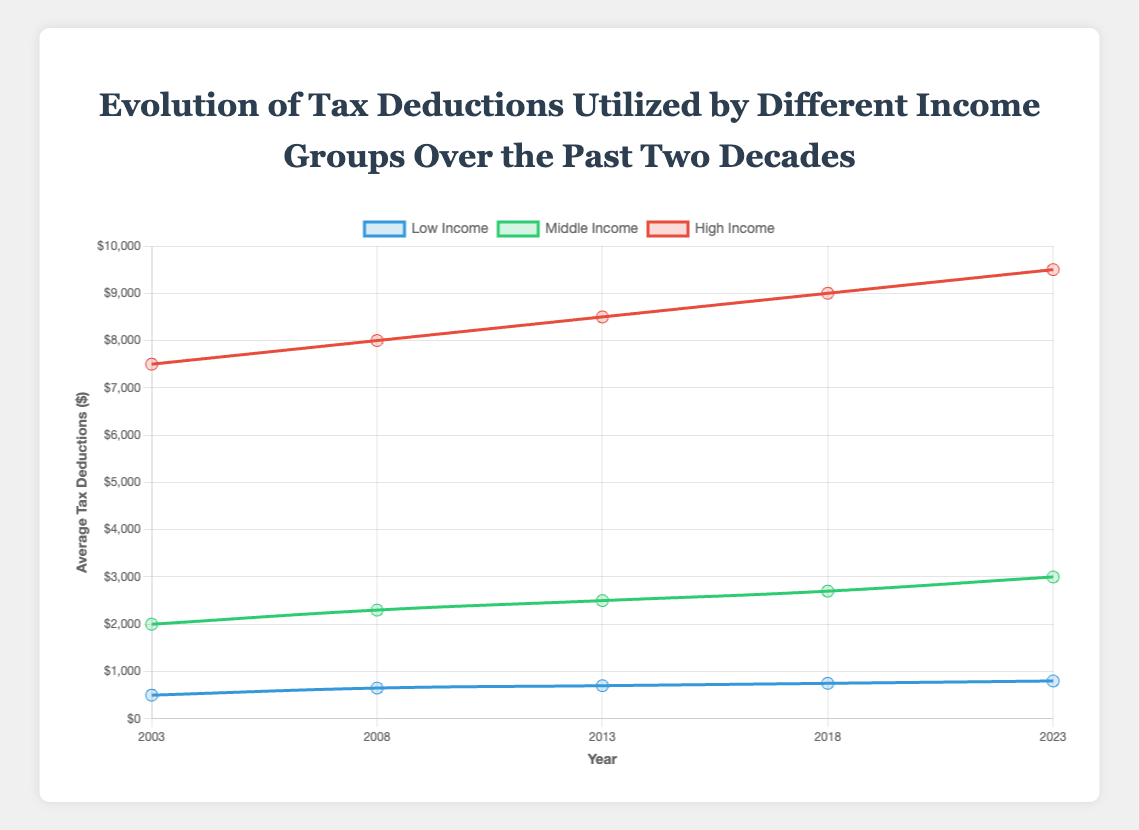What was the average tax deduction for the High Income group in 2003? Look at the curve labeled "High Income" for the year 2003. The data point shows an average tax deduction of $7500.
Answer: $7500 How did the average tax deductions for the Low Income group change from 2003 to 2023? Find the data points for the Low Income group for the years 2003 and 2023. In 2003, the average was $500, and in 2023 it was $800. The change is $800 - $500 = $300.
Answer: Increased by $300 Which income group had the highest average tax deductions in 2023? Look at the data points for 2023 across all income groups. The High Income group has the highest average tax deductions at $9500.
Answer: High Income What is the difference between the average tax deductions of the High Income group and the Middle Income group in 2018? Find the average tax deductions for the High Income group ($9000) and the Middle Income group ($2700) in 2018. The difference is $9000 - $2700 = $6300.
Answer: $6300 Did the Middle Income group's average tax deductions increase or decrease from 2003 to 2008? Look at the data points for the Middle Income group for the years 2003 ($2000) and 2008 ($2300). The average tax deductions increased by $2300 - $2000 = $300.
Answer: Increased Which income group showed the least increase in average tax deductions from 2003 to 2023? Calculate the increase for each group over the period. Low Income: $800 - $500 = $300, Middle Income: $3000 - $2000 = $1000, High Income: $9500 - $7500 = $2000. The Low Income group had the least increase.
Answer: Low Income How much did the average tax deductions for the Low Income group increase every 5 years on average from 2003 to 2023? Calculate the total increase from 2003 ($500) to 2023 ($800), which is $300. Since there are four 5-year intervals, divide the increase by 4: $300 / 4 = $75.
Answer: $75 Compare the trend of average tax deductions for Middle Income and High Income groups from 2003 to 2023. Which group had a steadier increase? Observe the points on the curves for both groups. The Middle Income group's increments are consistent (2000 -> 2300 -> 2500 -> 2700 -> 3000), while the High Income group showed larger jumps (7500 -> 8000 -> 8500 -> 9000 -> 9500). The Middle Income group had a steadier increase.
Answer: Middle Income What was the percentage increase in average tax deductions for the High Income group from 2003 to 2023? Use the values for 2003 ($7500) and 2023 ($9500). The increase is $9500 - $7500 = $2000. Calculate the percentage increase: ($2000 / $7500) * 100 = 26.67%.
Answer: 26.67% By 2023, which income group's average tax deductions closest to quadrupling compared to their 2003 values? Calculate 4 times the 2003 values: Low Income = $500 * 4 = $2000, Middle Income = $2000 * 4 = $8000, High Income = $7500 * 4 = $30000. Compare these targets with the 2023 values. Only the Middle Income group ($3000) is close considering the significant increase.
Answer: Middle Income 